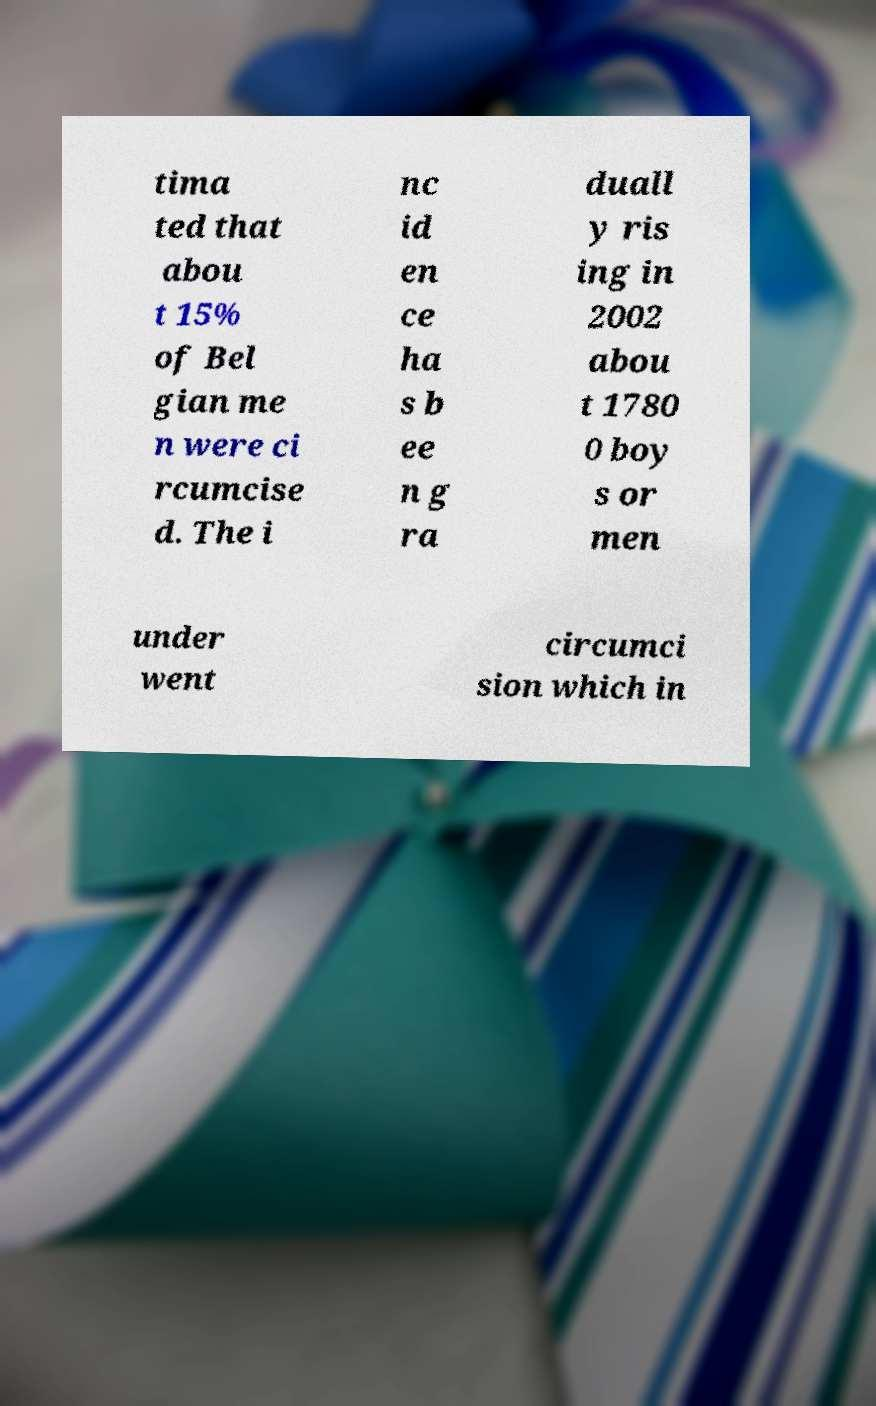Can you read and provide the text displayed in the image?This photo seems to have some interesting text. Can you extract and type it out for me? tima ted that abou t 15% of Bel gian me n were ci rcumcise d. The i nc id en ce ha s b ee n g ra duall y ris ing in 2002 abou t 1780 0 boy s or men under went circumci sion which in 